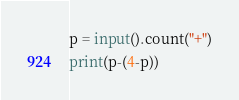<code> <loc_0><loc_0><loc_500><loc_500><_Python_>p = input().count("+")
print(p-(4-p))</code> 